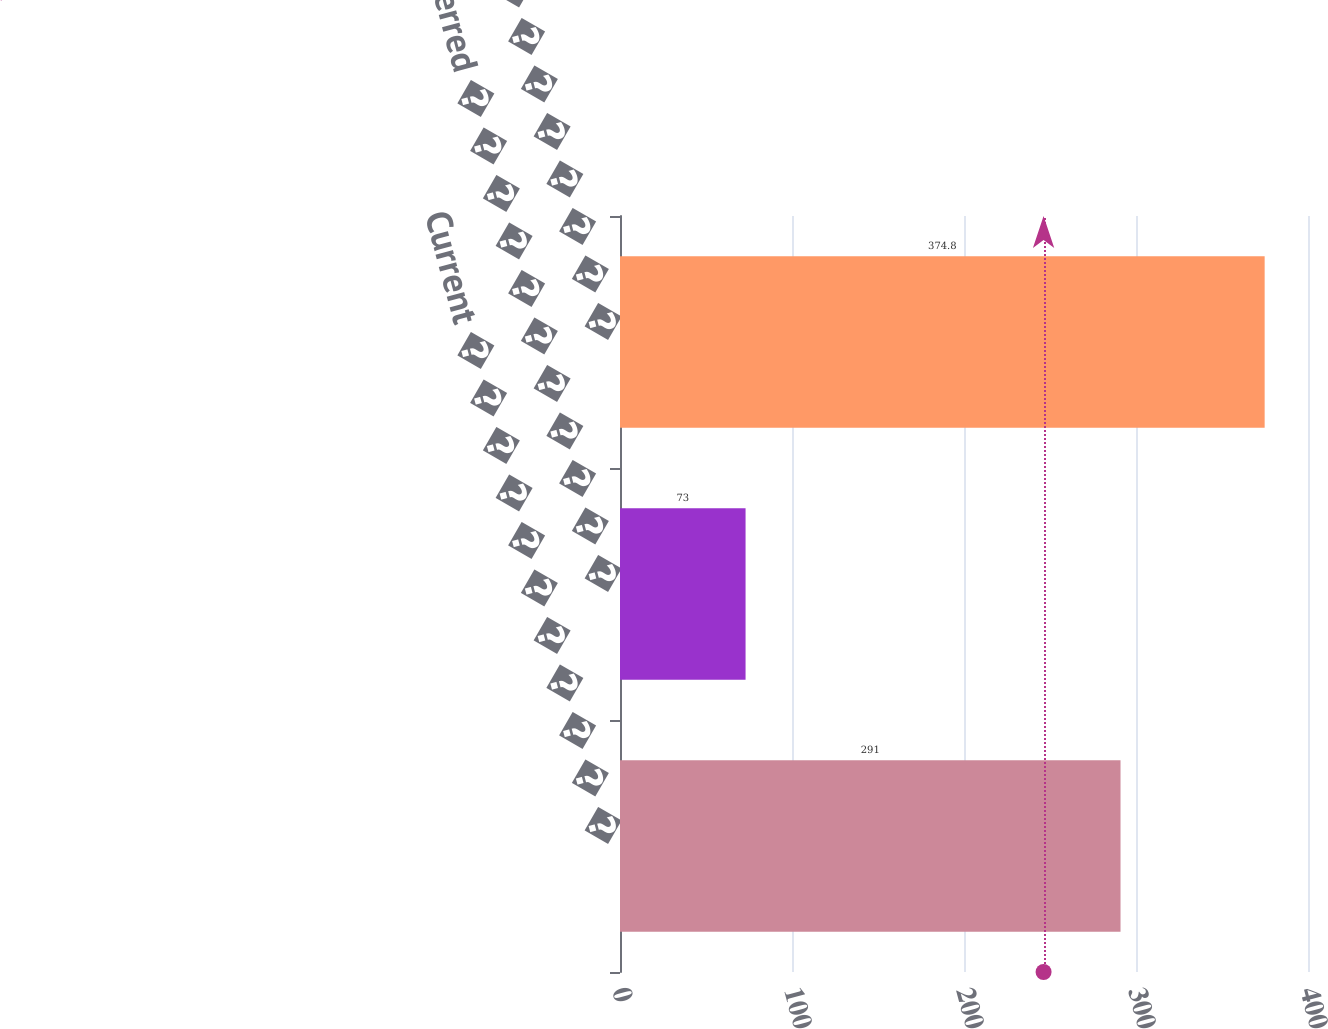Convert chart to OTSL. <chart><loc_0><loc_0><loc_500><loc_500><bar_chart><fcel>Current � � � � � � � � � � �<fcel>Deferred � � � � � � � � � � �<fcel>Total � � � � � � � � � � � �<nl><fcel>291<fcel>73<fcel>374.8<nl></chart> 